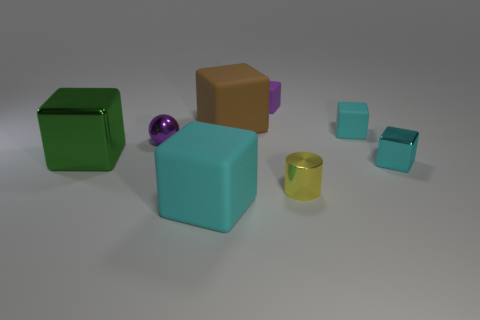Are any metal spheres visible?
Keep it short and to the point. Yes. Are there more small things in front of the green shiny cube than large cyan rubber cubes right of the large cyan matte cube?
Offer a very short reply. Yes. There is a tiny object on the left side of the large thing in front of the small yellow shiny thing; what is its color?
Your answer should be compact. Purple. Is there another shiny cylinder that has the same color as the cylinder?
Give a very brief answer. No. There is a purple thing to the left of the cyan rubber object that is on the left side of the cyan rubber object that is behind the purple sphere; how big is it?
Keep it short and to the point. Small. What is the shape of the purple metallic object?
Keep it short and to the point. Sphere. What is the size of the rubber thing that is the same color as the small ball?
Ensure brevity in your answer.  Small. There is a shiny block that is on the right side of the brown cube; how many objects are behind it?
Give a very brief answer. 5. What number of other objects are the same material as the large brown cube?
Provide a succinct answer. 3. Is the material of the cyan object on the left side of the purple matte thing the same as the small object that is on the left side of the brown matte object?
Provide a succinct answer. No. 